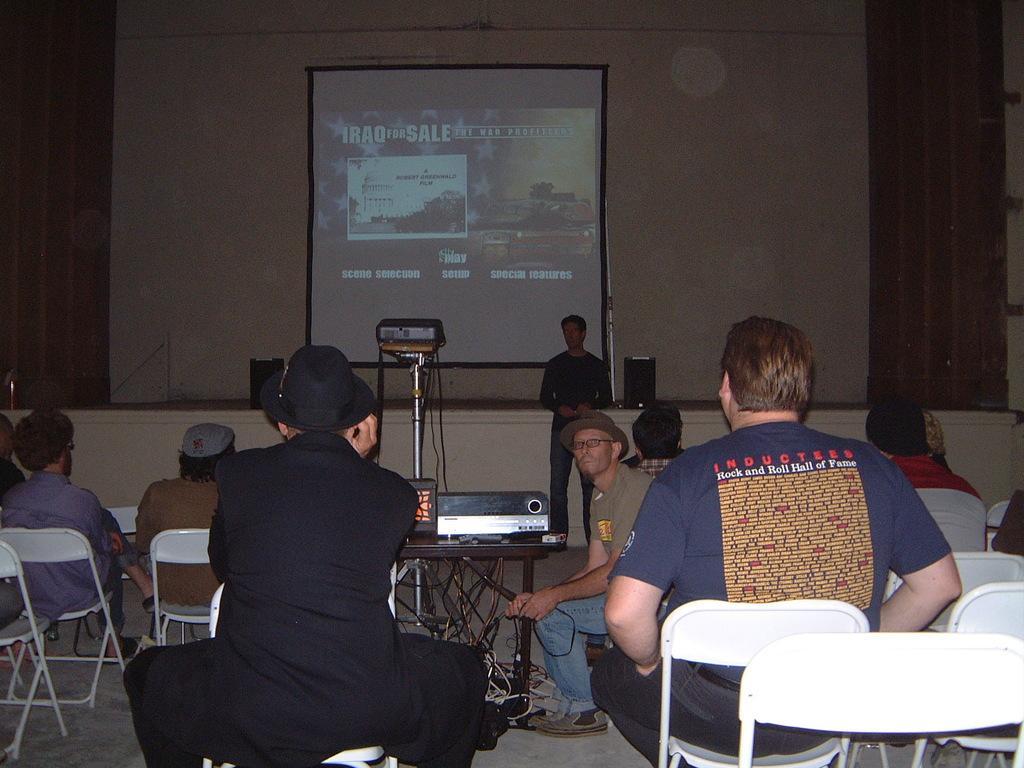In one or two sentences, can you explain what this image depicts? This picture shows few people seated on the chairs and we see a man standing we see a projector screen and a projector 